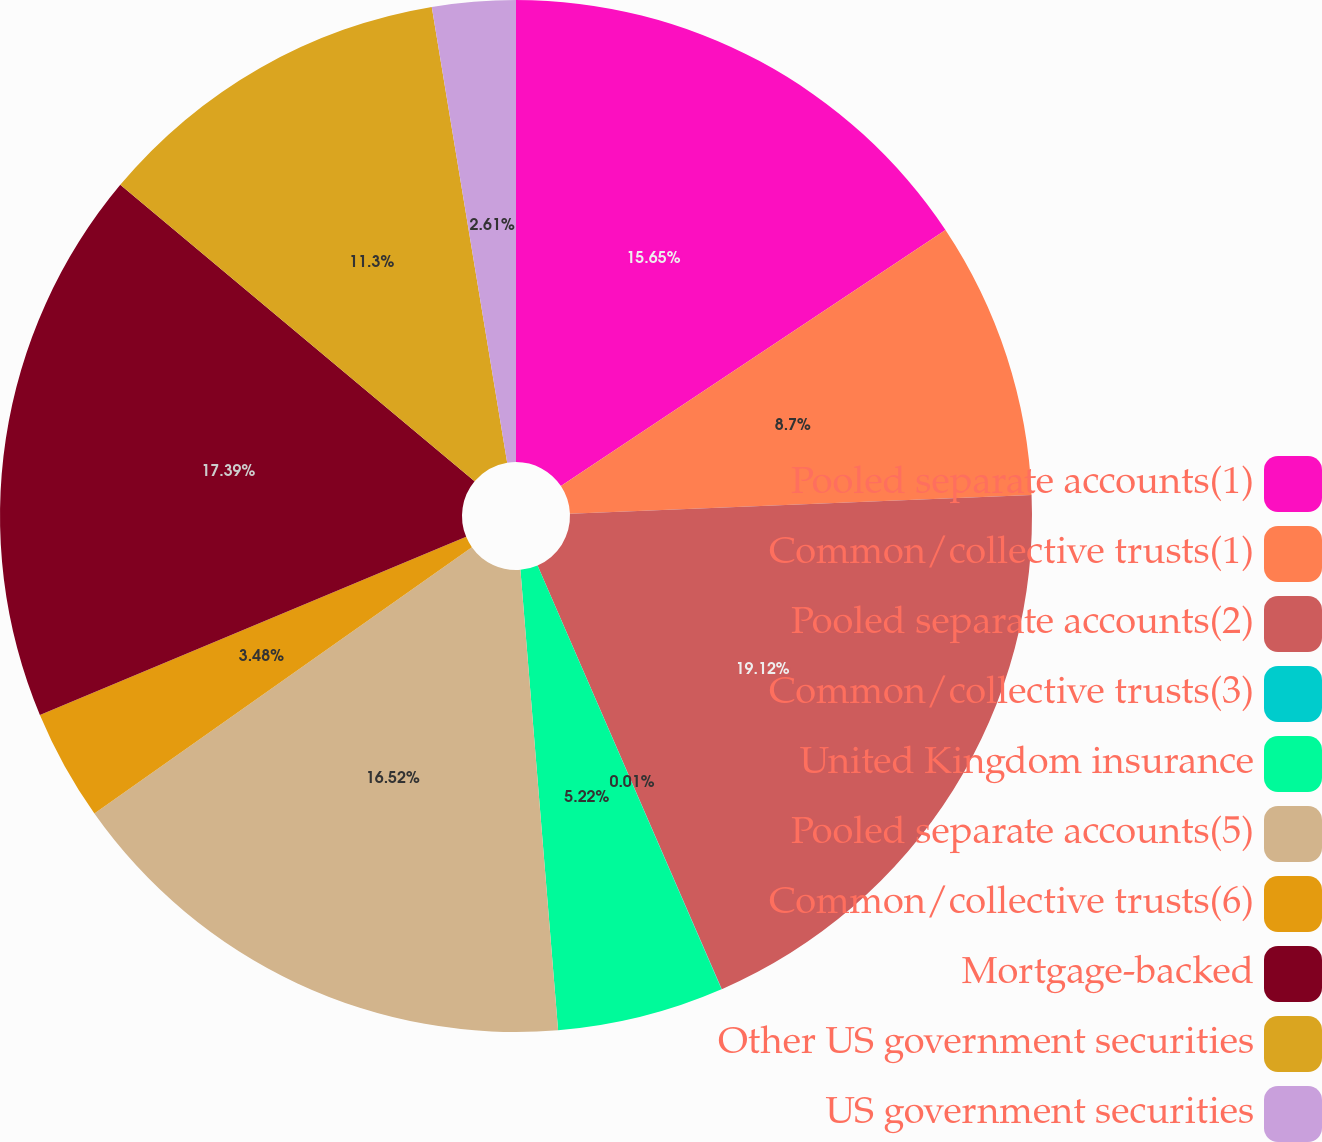Convert chart to OTSL. <chart><loc_0><loc_0><loc_500><loc_500><pie_chart><fcel>Pooled separate accounts(1)<fcel>Common/collective trusts(1)<fcel>Pooled separate accounts(2)<fcel>Common/collective trusts(3)<fcel>United Kingdom insurance<fcel>Pooled separate accounts(5)<fcel>Common/collective trusts(6)<fcel>Mortgage-backed<fcel>Other US government securities<fcel>US government securities<nl><fcel>15.65%<fcel>8.7%<fcel>19.12%<fcel>0.01%<fcel>5.22%<fcel>16.52%<fcel>3.48%<fcel>17.39%<fcel>11.3%<fcel>2.61%<nl></chart> 